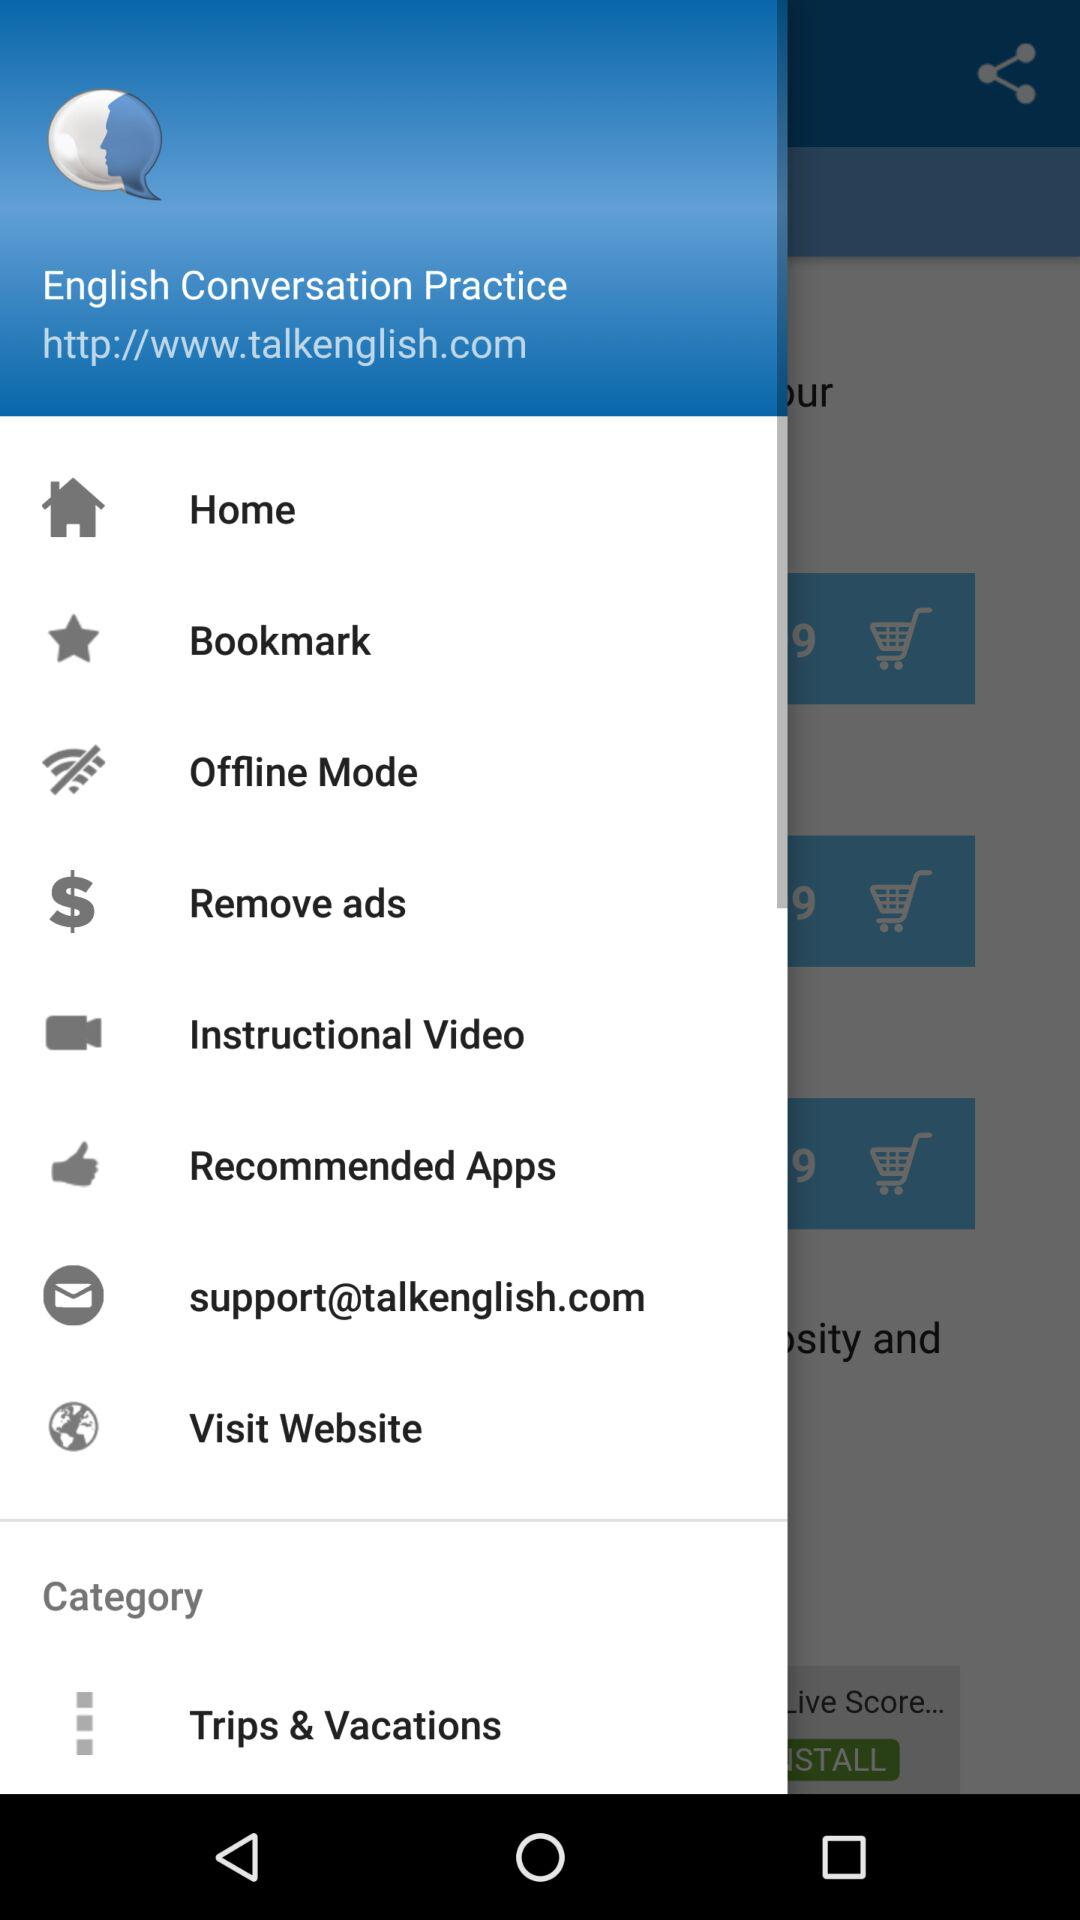What is the email address? The email address is support@talkenglish.com. 